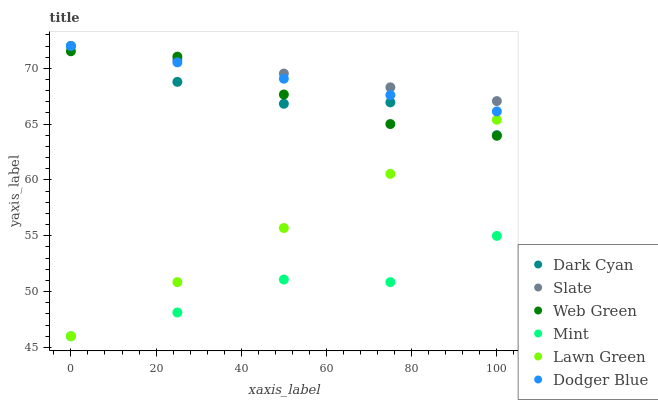Does Mint have the minimum area under the curve?
Answer yes or no. Yes. Does Slate have the maximum area under the curve?
Answer yes or no. Yes. Does Web Green have the minimum area under the curve?
Answer yes or no. No. Does Web Green have the maximum area under the curve?
Answer yes or no. No. Is Lawn Green the smoothest?
Answer yes or no. Yes. Is Mint the roughest?
Answer yes or no. Yes. Is Slate the smoothest?
Answer yes or no. No. Is Slate the roughest?
Answer yes or no. No. Does Lawn Green have the lowest value?
Answer yes or no. Yes. Does Web Green have the lowest value?
Answer yes or no. No. Does Dark Cyan have the highest value?
Answer yes or no. Yes. Does Web Green have the highest value?
Answer yes or no. No. Is Mint less than Dodger Blue?
Answer yes or no. Yes. Is Web Green greater than Mint?
Answer yes or no. Yes. Does Slate intersect Dark Cyan?
Answer yes or no. Yes. Is Slate less than Dark Cyan?
Answer yes or no. No. Is Slate greater than Dark Cyan?
Answer yes or no. No. Does Mint intersect Dodger Blue?
Answer yes or no. No. 